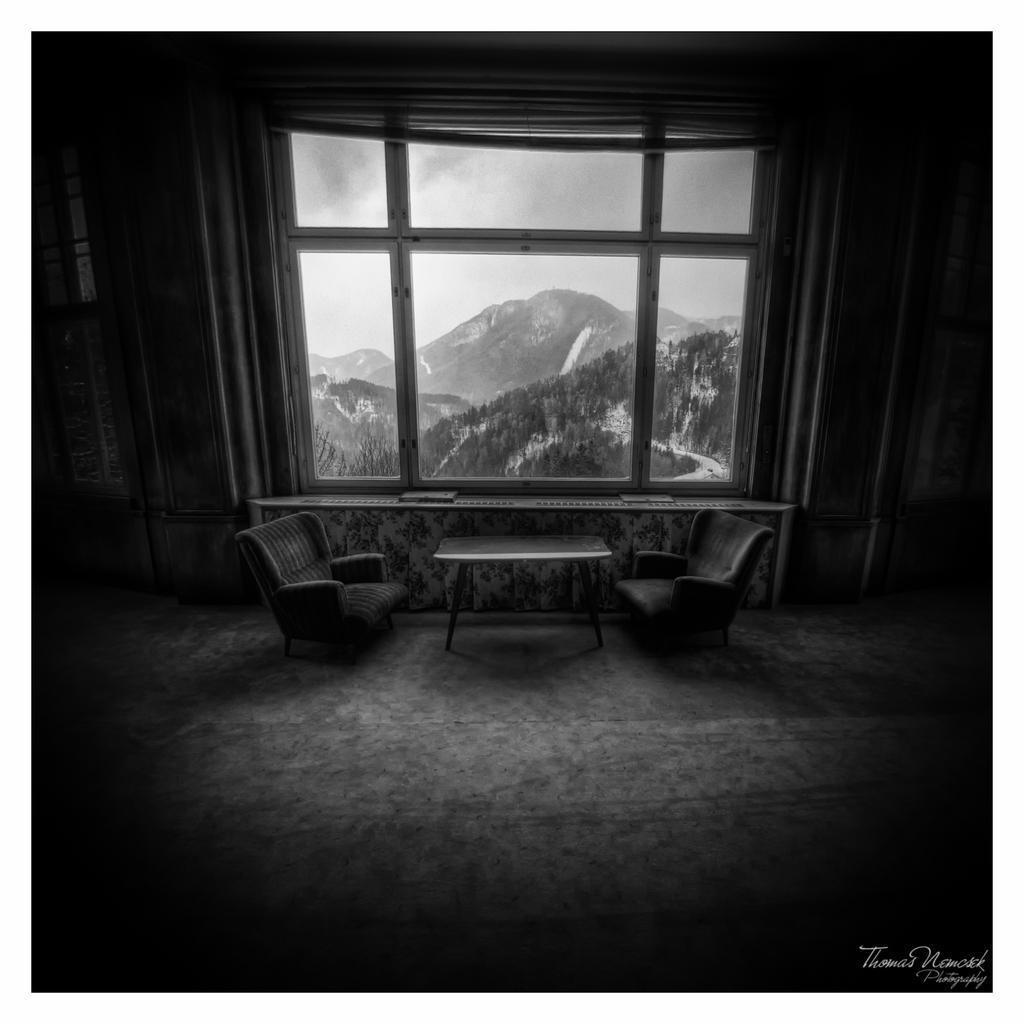Can you describe this image briefly? This picture shows an inner view of a house and we see two chairs and a table and we see some hills from the window of the house. 